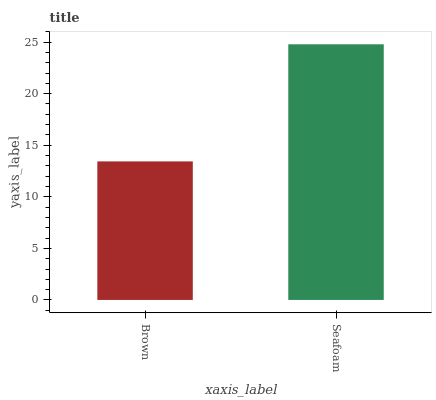Is Brown the minimum?
Answer yes or no. Yes. Is Seafoam the maximum?
Answer yes or no. Yes. Is Seafoam the minimum?
Answer yes or no. No. Is Seafoam greater than Brown?
Answer yes or no. Yes. Is Brown less than Seafoam?
Answer yes or no. Yes. Is Brown greater than Seafoam?
Answer yes or no. No. Is Seafoam less than Brown?
Answer yes or no. No. Is Seafoam the high median?
Answer yes or no. Yes. Is Brown the low median?
Answer yes or no. Yes. Is Brown the high median?
Answer yes or no. No. Is Seafoam the low median?
Answer yes or no. No. 